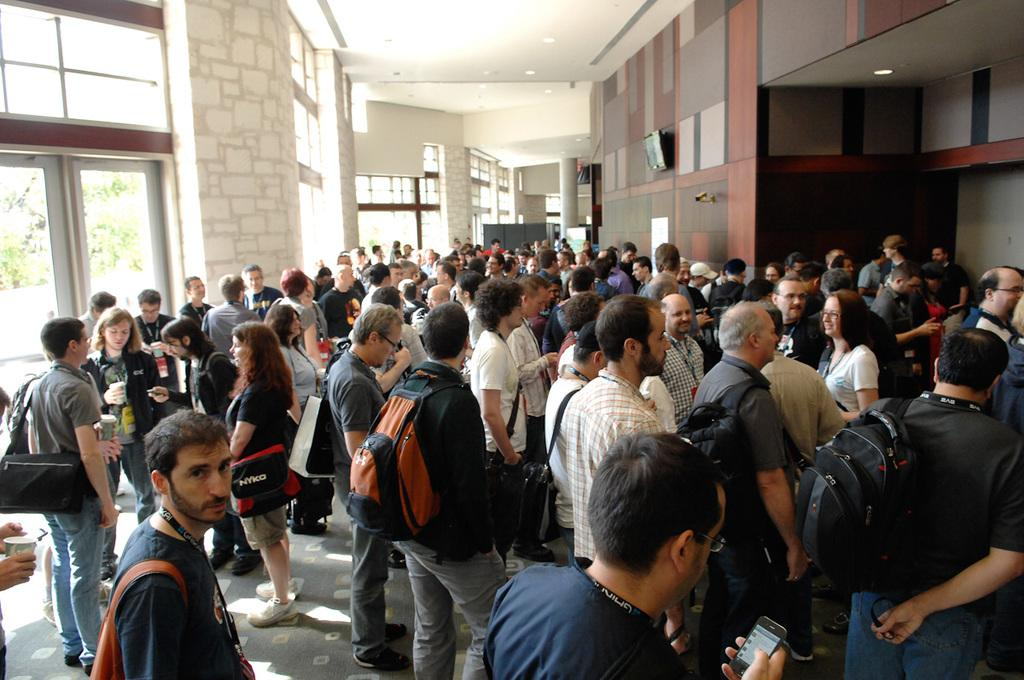What is the main subject of the image? The main subject of the image is a crowd. Where is the crowd located in the image? The crowd is at the bottom of the image. What can be seen in the background of the image? There is a wall in the background of the image. What architectural feature is present on the left side of the image? There is a glass door on the left side of the image. What type of representative can be seen addressing the crowd in the image? There is no representative addressing the crowd in the image; it only shows a crowd at the bottom of the image. What is the crowd's reaction to the disgusting bucket in the image? There is no bucket, let alone a disgusting one, present in the image. 